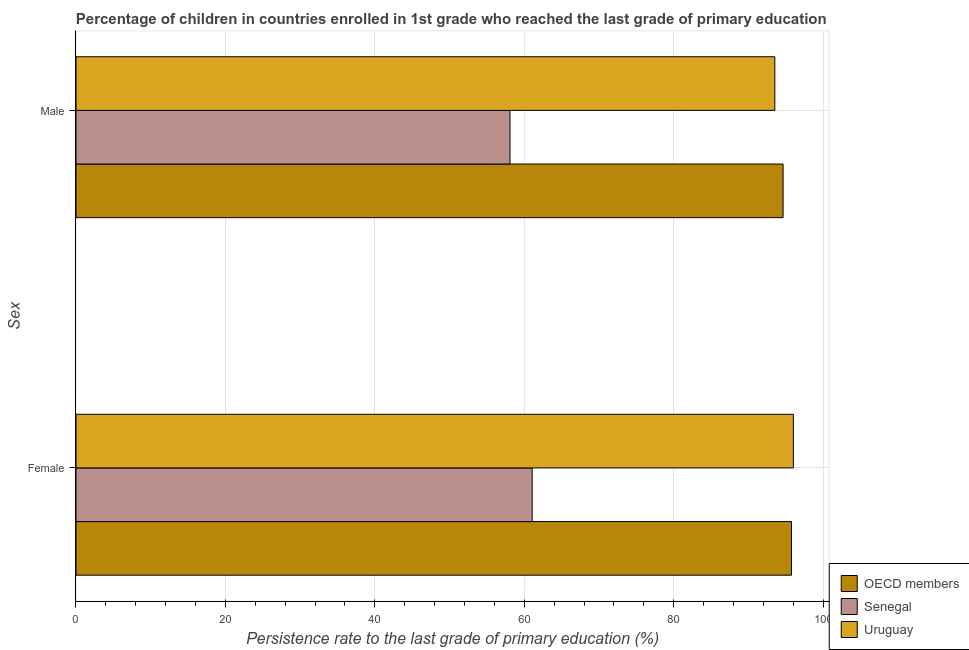How many different coloured bars are there?
Provide a succinct answer. 3. How many groups of bars are there?
Keep it short and to the point. 2. How many bars are there on the 1st tick from the top?
Provide a short and direct response. 3. What is the label of the 2nd group of bars from the top?
Your answer should be very brief. Female. What is the persistence rate of male students in Senegal?
Your response must be concise. 58.08. Across all countries, what is the maximum persistence rate of female students?
Provide a succinct answer. 96.02. Across all countries, what is the minimum persistence rate of male students?
Give a very brief answer. 58.08. In which country was the persistence rate of female students maximum?
Give a very brief answer. Uruguay. In which country was the persistence rate of male students minimum?
Your response must be concise. Senegal. What is the total persistence rate of male students in the graph?
Your response must be concise. 246.26. What is the difference between the persistence rate of female students in OECD members and that in Senegal?
Provide a succinct answer. 34.71. What is the difference between the persistence rate of male students in Uruguay and the persistence rate of female students in Senegal?
Provide a short and direct response. 32.47. What is the average persistence rate of male students per country?
Keep it short and to the point. 82.09. What is the difference between the persistence rate of male students and persistence rate of female students in Uruguay?
Keep it short and to the point. -2.48. What is the ratio of the persistence rate of female students in OECD members to that in Uruguay?
Offer a very short reply. 1. Is the persistence rate of female students in Uruguay less than that in Senegal?
Your answer should be very brief. No. What does the 2nd bar from the top in Male represents?
Offer a terse response. Senegal. What does the 1st bar from the bottom in Male represents?
Give a very brief answer. OECD members. Are all the bars in the graph horizontal?
Your response must be concise. Yes. What is the difference between two consecutive major ticks on the X-axis?
Your response must be concise. 20. Are the values on the major ticks of X-axis written in scientific E-notation?
Your answer should be compact. No. Does the graph contain any zero values?
Provide a short and direct response. No. Does the graph contain grids?
Make the answer very short. Yes. Where does the legend appear in the graph?
Give a very brief answer. Bottom right. What is the title of the graph?
Keep it short and to the point. Percentage of children in countries enrolled in 1st grade who reached the last grade of primary education. What is the label or title of the X-axis?
Make the answer very short. Persistence rate to the last grade of primary education (%). What is the label or title of the Y-axis?
Provide a short and direct response. Sex. What is the Persistence rate to the last grade of primary education (%) in OECD members in Female?
Provide a succinct answer. 95.77. What is the Persistence rate to the last grade of primary education (%) of Senegal in Female?
Offer a very short reply. 61.06. What is the Persistence rate to the last grade of primary education (%) of Uruguay in Female?
Ensure brevity in your answer.  96.02. What is the Persistence rate to the last grade of primary education (%) of OECD members in Male?
Your answer should be very brief. 94.64. What is the Persistence rate to the last grade of primary education (%) in Senegal in Male?
Ensure brevity in your answer.  58.08. What is the Persistence rate to the last grade of primary education (%) of Uruguay in Male?
Ensure brevity in your answer.  93.53. Across all Sex, what is the maximum Persistence rate to the last grade of primary education (%) in OECD members?
Keep it short and to the point. 95.77. Across all Sex, what is the maximum Persistence rate to the last grade of primary education (%) of Senegal?
Give a very brief answer. 61.06. Across all Sex, what is the maximum Persistence rate to the last grade of primary education (%) in Uruguay?
Offer a very short reply. 96.02. Across all Sex, what is the minimum Persistence rate to the last grade of primary education (%) of OECD members?
Keep it short and to the point. 94.64. Across all Sex, what is the minimum Persistence rate to the last grade of primary education (%) of Senegal?
Keep it short and to the point. 58.08. Across all Sex, what is the minimum Persistence rate to the last grade of primary education (%) in Uruguay?
Provide a short and direct response. 93.53. What is the total Persistence rate to the last grade of primary education (%) in OECD members in the graph?
Make the answer very short. 190.41. What is the total Persistence rate to the last grade of primary education (%) in Senegal in the graph?
Your response must be concise. 119.14. What is the total Persistence rate to the last grade of primary education (%) in Uruguay in the graph?
Keep it short and to the point. 189.55. What is the difference between the Persistence rate to the last grade of primary education (%) in OECD members in Female and that in Male?
Ensure brevity in your answer.  1.13. What is the difference between the Persistence rate to the last grade of primary education (%) in Senegal in Female and that in Male?
Provide a succinct answer. 2.97. What is the difference between the Persistence rate to the last grade of primary education (%) in Uruguay in Female and that in Male?
Offer a very short reply. 2.48. What is the difference between the Persistence rate to the last grade of primary education (%) in OECD members in Female and the Persistence rate to the last grade of primary education (%) in Senegal in Male?
Offer a terse response. 37.68. What is the difference between the Persistence rate to the last grade of primary education (%) in OECD members in Female and the Persistence rate to the last grade of primary education (%) in Uruguay in Male?
Provide a succinct answer. 2.24. What is the difference between the Persistence rate to the last grade of primary education (%) of Senegal in Female and the Persistence rate to the last grade of primary education (%) of Uruguay in Male?
Give a very brief answer. -32.47. What is the average Persistence rate to the last grade of primary education (%) of OECD members per Sex?
Offer a terse response. 95.2. What is the average Persistence rate to the last grade of primary education (%) of Senegal per Sex?
Make the answer very short. 59.57. What is the average Persistence rate to the last grade of primary education (%) in Uruguay per Sex?
Make the answer very short. 94.77. What is the difference between the Persistence rate to the last grade of primary education (%) of OECD members and Persistence rate to the last grade of primary education (%) of Senegal in Female?
Ensure brevity in your answer.  34.71. What is the difference between the Persistence rate to the last grade of primary education (%) in OECD members and Persistence rate to the last grade of primary education (%) in Uruguay in Female?
Keep it short and to the point. -0.25. What is the difference between the Persistence rate to the last grade of primary education (%) in Senegal and Persistence rate to the last grade of primary education (%) in Uruguay in Female?
Offer a very short reply. -34.96. What is the difference between the Persistence rate to the last grade of primary education (%) in OECD members and Persistence rate to the last grade of primary education (%) in Senegal in Male?
Offer a terse response. 36.56. What is the difference between the Persistence rate to the last grade of primary education (%) in OECD members and Persistence rate to the last grade of primary education (%) in Uruguay in Male?
Ensure brevity in your answer.  1.11. What is the difference between the Persistence rate to the last grade of primary education (%) in Senegal and Persistence rate to the last grade of primary education (%) in Uruguay in Male?
Offer a terse response. -35.45. What is the ratio of the Persistence rate to the last grade of primary education (%) of OECD members in Female to that in Male?
Provide a succinct answer. 1.01. What is the ratio of the Persistence rate to the last grade of primary education (%) in Senegal in Female to that in Male?
Offer a terse response. 1.05. What is the ratio of the Persistence rate to the last grade of primary education (%) of Uruguay in Female to that in Male?
Ensure brevity in your answer.  1.03. What is the difference between the highest and the second highest Persistence rate to the last grade of primary education (%) in OECD members?
Keep it short and to the point. 1.13. What is the difference between the highest and the second highest Persistence rate to the last grade of primary education (%) in Senegal?
Provide a succinct answer. 2.97. What is the difference between the highest and the second highest Persistence rate to the last grade of primary education (%) of Uruguay?
Offer a terse response. 2.48. What is the difference between the highest and the lowest Persistence rate to the last grade of primary education (%) in OECD members?
Give a very brief answer. 1.13. What is the difference between the highest and the lowest Persistence rate to the last grade of primary education (%) in Senegal?
Your answer should be very brief. 2.97. What is the difference between the highest and the lowest Persistence rate to the last grade of primary education (%) of Uruguay?
Provide a short and direct response. 2.48. 